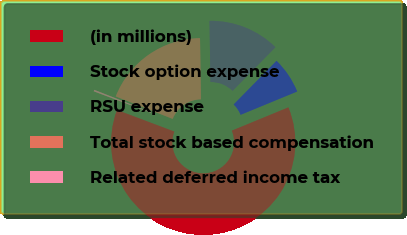Convert chart. <chart><loc_0><loc_0><loc_500><loc_500><pie_chart><fcel>(in millions)<fcel>Stock option expense<fcel>RSU expense<fcel>Total stock based compensation<fcel>Related deferred income tax<nl><fcel>61.95%<fcel>6.43%<fcel>12.6%<fcel>18.77%<fcel>0.26%<nl></chart> 